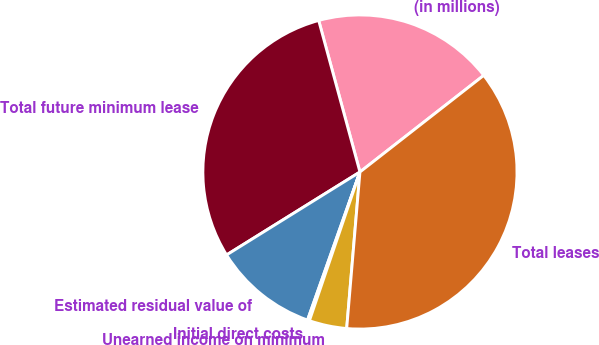Convert chart to OTSL. <chart><loc_0><loc_0><loc_500><loc_500><pie_chart><fcel>(in millions)<fcel>Total future minimum lease<fcel>Estimated residual value of<fcel>Initial direct costs<fcel>Unearned income on minimum<fcel>Total leases<nl><fcel>18.68%<fcel>29.62%<fcel>10.73%<fcel>0.2%<fcel>3.87%<fcel>36.89%<nl></chart> 